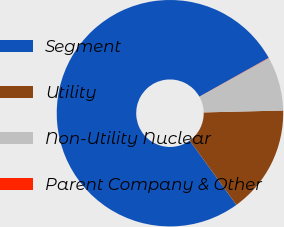Convert chart to OTSL. <chart><loc_0><loc_0><loc_500><loc_500><pie_chart><fcel>Segment<fcel>Utility<fcel>Non-Utility Nuclear<fcel>Parent Company & Other<nl><fcel>76.84%<fcel>15.4%<fcel>7.72%<fcel>0.04%<nl></chart> 